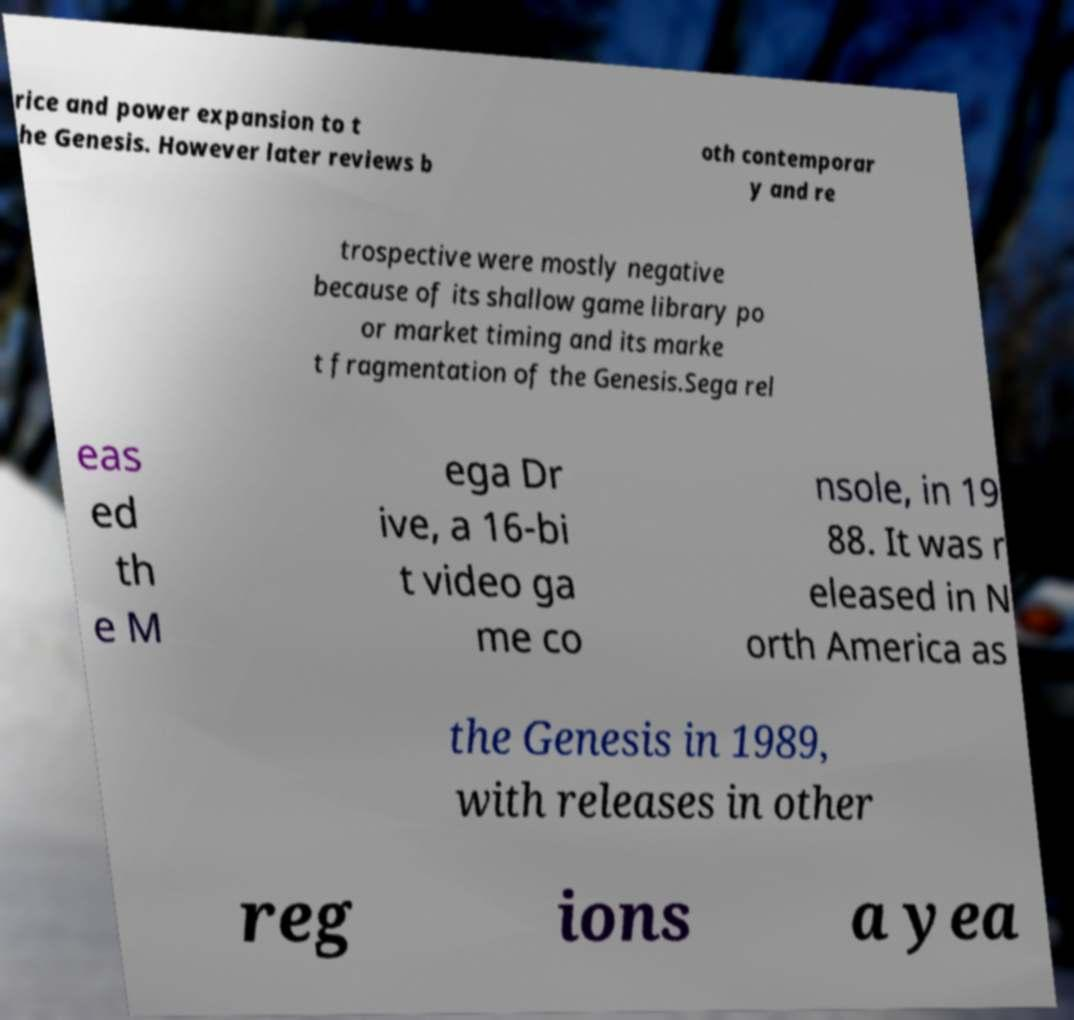Could you assist in decoding the text presented in this image and type it out clearly? rice and power expansion to t he Genesis. However later reviews b oth contemporar y and re trospective were mostly negative because of its shallow game library po or market timing and its marke t fragmentation of the Genesis.Sega rel eas ed th e M ega Dr ive, a 16-bi t video ga me co nsole, in 19 88. It was r eleased in N orth America as the Genesis in 1989, with releases in other reg ions a yea 